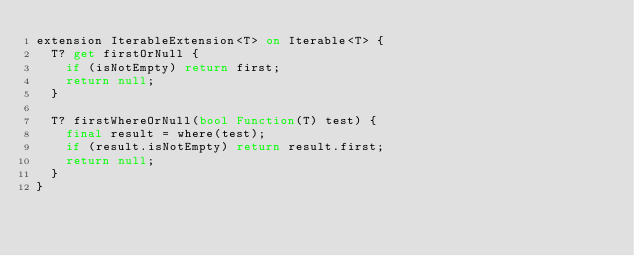<code> <loc_0><loc_0><loc_500><loc_500><_Dart_>extension IterableExtension<T> on Iterable<T> {
  T? get firstOrNull {
    if (isNotEmpty) return first;
    return null;
  }

  T? firstWhereOrNull(bool Function(T) test) {
    final result = where(test);
    if (result.isNotEmpty) return result.first;
    return null;
  }
}
</code> 